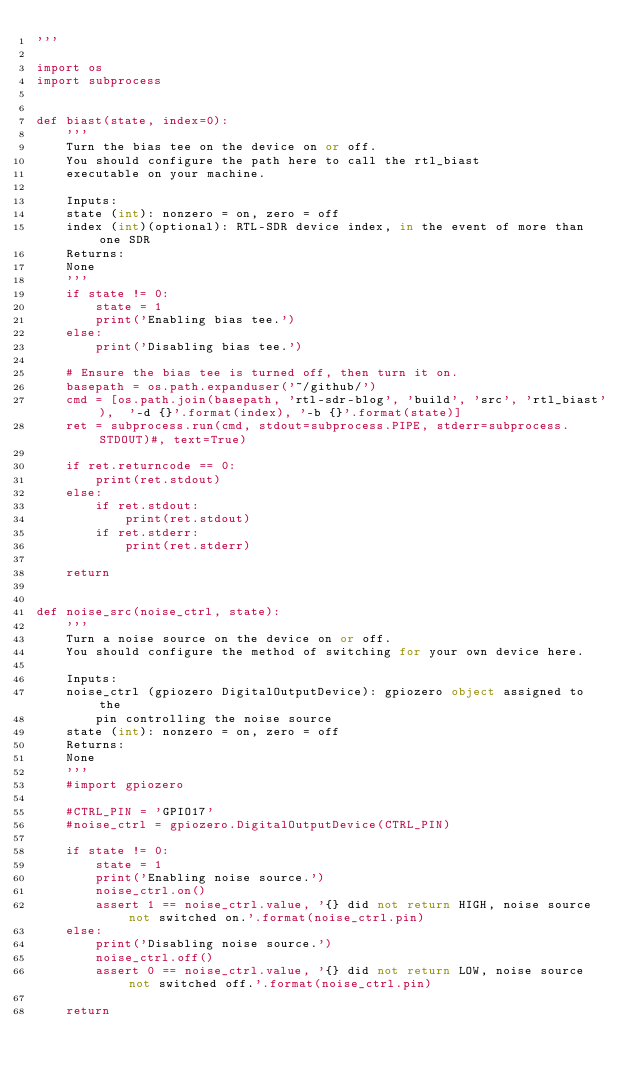<code> <loc_0><loc_0><loc_500><loc_500><_Python_>'''

import os
import subprocess


def biast(state, index=0):
    '''
    Turn the bias tee on the device on or off.
    You should configure the path here to call the rtl_biast
    executable on your machine.

    Inputs:
    state (int): nonzero = on, zero = off
    index (int)(optional): RTL-SDR device index, in the event of more than one SDR
    Returns:
    None
    '''
    if state != 0:
        state = 1
        print('Enabling bias tee.')
    else:
        print('Disabling bias tee.')

    # Ensure the bias tee is turned off, then turn it on.                       
    basepath = os.path.expanduser('~/github/')
    cmd = [os.path.join(basepath, 'rtl-sdr-blog', 'build', 'src', 'rtl_biast'),  '-d {}'.format(index), '-b {}'.format(state)]
    ret = subprocess.run(cmd, stdout=subprocess.PIPE, stderr=subprocess.STDOUT)#, text=True)

    if ret.returncode == 0:
        print(ret.stdout)
    else:
        if ret.stdout:
            print(ret.stdout)
        if ret.stderr:
            print(ret.stderr)

    return


def noise_src(noise_ctrl, state):
    '''
    Turn a noise source on the device on or off.
    You should configure the method of switching for your own device here.

    Inputs:
    noise_ctrl (gpiozero DigitalOutputDevice): gpiozero object assigned to the
        pin controlling the noise source
    state (int): nonzero = on, zero = off
    Returns:
    None
    '''
    #import gpiozero
    
    #CTRL_PIN = 'GPIO17'
    #noise_ctrl = gpiozero.DigitalOutputDevice(CTRL_PIN) 

    if state != 0:
        state = 1
        print('Enabling noise source.')
        noise_ctrl.on()
        assert 1 == noise_ctrl.value, '{} did not return HIGH, noise source not switched on.'.format(noise_ctrl.pin)
    else:
        print('Disabling noise source.')
        noise_ctrl.off()
        assert 0 == noise_ctrl.value, '{} did not return LOW, noise source not switched off.'.format(noise_ctrl.pin)

    return
</code> 